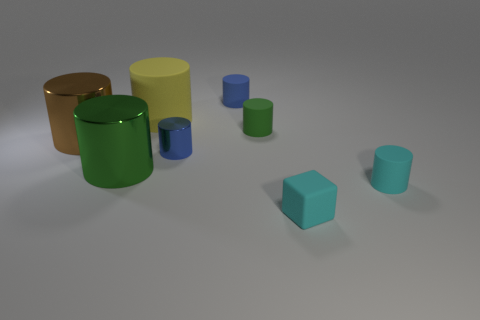There is a brown cylinder that is the same size as the yellow cylinder; what material is it?
Provide a short and direct response. Metal. What material is the blue cylinder that is in front of the tiny blue object behind the tiny metal cylinder in front of the big brown shiny cylinder made of?
Give a very brief answer. Metal. Is the size of the blue metal cylinder that is on the right side of the yellow matte thing the same as the yellow cylinder?
Provide a short and direct response. No. Are there more small matte balls than metallic cylinders?
Ensure brevity in your answer.  No. What number of tiny things are either cyan cylinders or brown cylinders?
Provide a succinct answer. 1. How many other things are the same color as the tiny shiny cylinder?
Make the answer very short. 1. How many large brown cylinders have the same material as the big green cylinder?
Keep it short and to the point. 1. Does the small cylinder that is behind the large yellow thing have the same color as the tiny cube?
Your answer should be very brief. No. How many green things are matte cylinders or rubber cubes?
Provide a succinct answer. 1. Are there any other things that are the same material as the tiny green thing?
Ensure brevity in your answer.  Yes. 